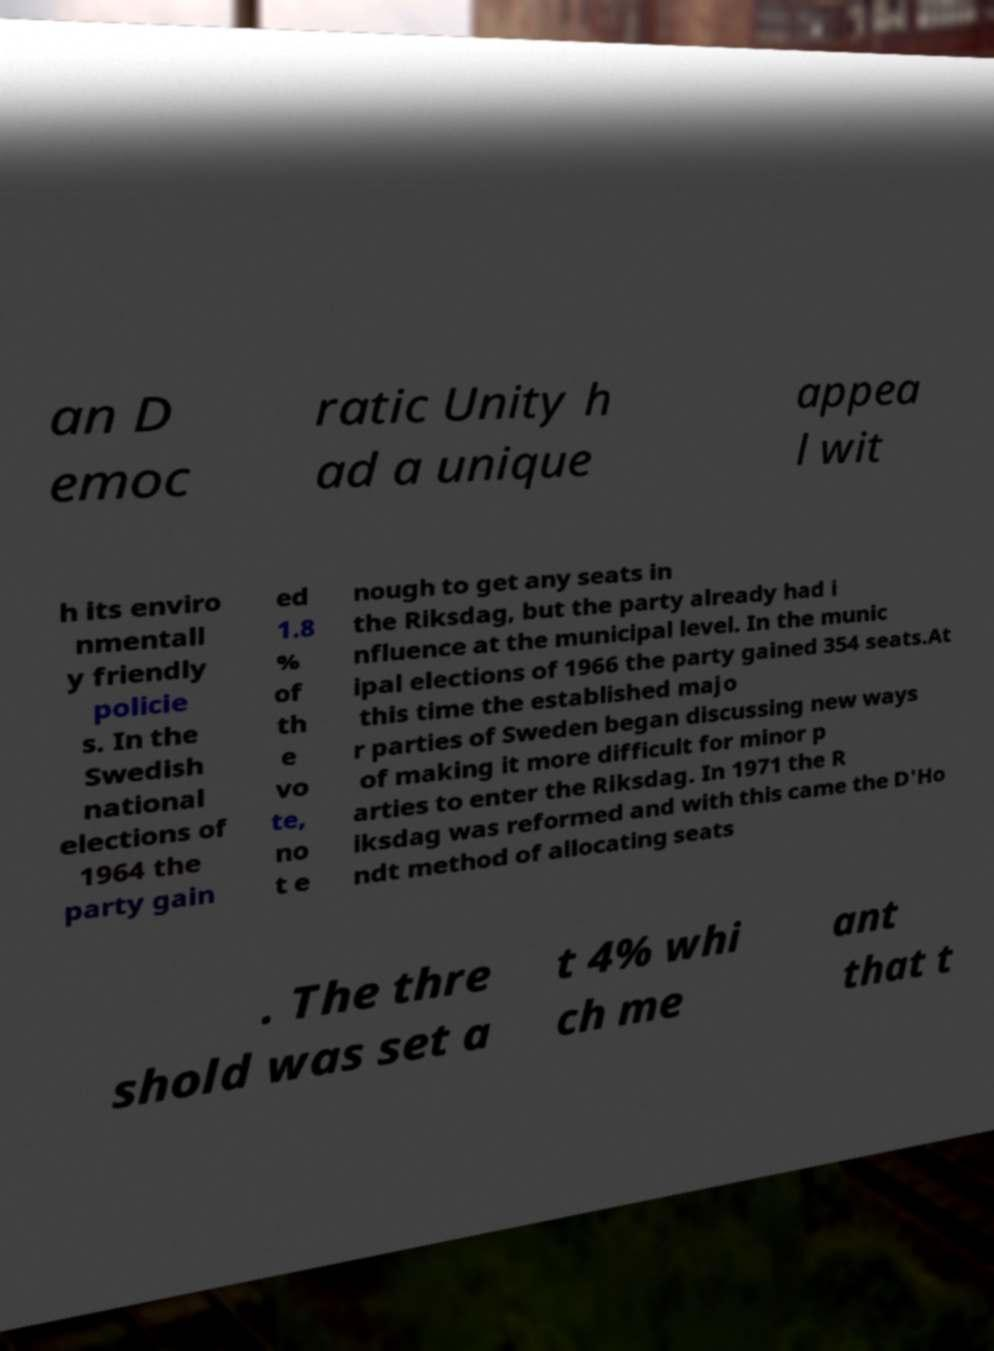For documentation purposes, I need the text within this image transcribed. Could you provide that? an D emoc ratic Unity h ad a unique appea l wit h its enviro nmentall y friendly policie s. In the Swedish national elections of 1964 the party gain ed 1.8 % of th e vo te, no t e nough to get any seats in the Riksdag, but the party already had i nfluence at the municipal level. In the munic ipal elections of 1966 the party gained 354 seats.At this time the established majo r parties of Sweden began discussing new ways of making it more difficult for minor p arties to enter the Riksdag. In 1971 the R iksdag was reformed and with this came the D'Ho ndt method of allocating seats . The thre shold was set a t 4% whi ch me ant that t 